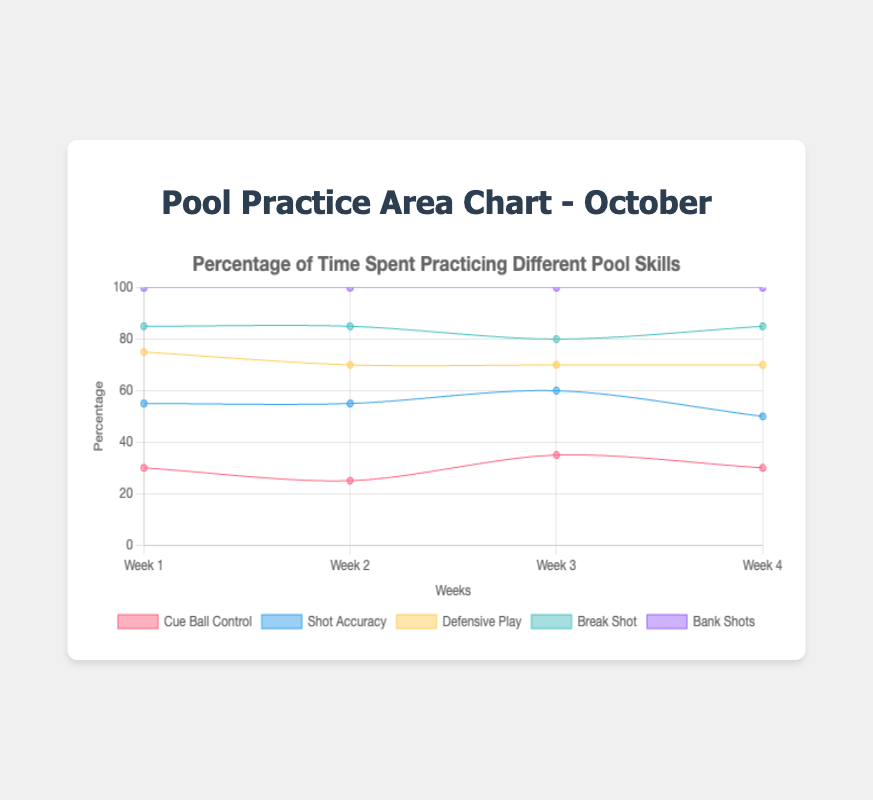what is the title of the figure? The title of the figure is displayed prominently at the top. It reads "Percentage of Time Spent Practicing Different Pool Skills."
Answer: Percentage of Time Spent Practicing Different Pool Skills Which skill had the largest increase in practice time between Week 2 and Week 3? To determine the largest increase in practice time between Week 2 and Week 3, we compare the differences for each skill. For Cue Ball Control, the increase is 35 - 25 = 10. For Shot Accuracy, it's 25 - 30 = -5 (a decrease). For Defensive Play, it's 10 - 15 = -5 (a decrease). For Break Shot, it's 10. For Bank Shots, it’s 5. Therefore, the skill with the largest increase is Cue Ball Control.
Answer: Cue Ball Control Which week shows the highest practice time for Shot Accuracy? By looking at the data points for Shot Accuracy across all weeks, we have: 25 in Week 1, 30 in Week 2, 25 in Week 3, and 20 in Week 4. The highest value is 30, which occurs in Week 2.
Answer: Week 2 What is the total percentage of practice time spent on Break Shot over the month? To find the total practice time for Break Shot over the month, sum the weekly data: 10 (Week 1) + 15 (Week 2) + 10 (Week 3) + 15 (Week 4) = 50%.
Answer: 50% On which week does Defensive Play have the lowest practice time, and what is the percentage? By examining the data for Defensive Play, we see that Week 3 has the lowest value at 10%. This is the smallest number compared to other weeks (20, 15, 20).
Answer: Week 3, 10% How does the total practice time spent on Bank Shots compare to Cue Ball Control for Week 1? Comparing Week 1 for both skills, we have Cue Ball Control at 30% and Bank Shots at 15%. Cue Ball Control is 15% higher than Bank Shots for Week 1.
Answer: Cue Ball Control is 15% higher What is the average percentage of practice time spent on Shot Accuracy across all weeks? To find the average, sum up the percentages for Shot Accuracy across weeks and divide by 4. (25 + 30 + 25 + 20) / 4 = 100 / 4 = 25%.
Answer: 25% What percentage of practice time was spent on all skills combined during Week 2? Adding the percentages for all skills in Week 2: 25 (Cue Ball Control) + 30 (Shot Accuracy) + 15 (Defensive Play) + 15 (Break Shot) + 15 (Bank Shots) = 100%.
Answer: 100% Which skill shows the most consistent practice time across all weeks? To determine the most consistent practice time, we look at the data variability across weeks. Bank Shots remain at 15 for Weeks 1, 2, and 4, with only a slight change to 20 in Week 3. The other skills show more variability. Therefore, Bank Shots is the most consistent.
Answer: Bank Shots 